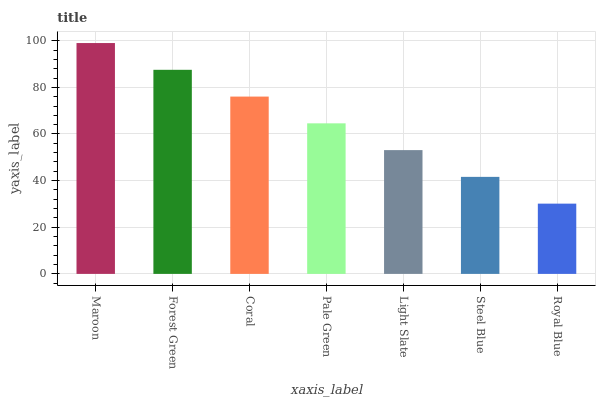Is Royal Blue the minimum?
Answer yes or no. Yes. Is Maroon the maximum?
Answer yes or no. Yes. Is Forest Green the minimum?
Answer yes or no. No. Is Forest Green the maximum?
Answer yes or no. No. Is Maroon greater than Forest Green?
Answer yes or no. Yes. Is Forest Green less than Maroon?
Answer yes or no. Yes. Is Forest Green greater than Maroon?
Answer yes or no. No. Is Maroon less than Forest Green?
Answer yes or no. No. Is Pale Green the high median?
Answer yes or no. Yes. Is Pale Green the low median?
Answer yes or no. Yes. Is Maroon the high median?
Answer yes or no. No. Is Steel Blue the low median?
Answer yes or no. No. 